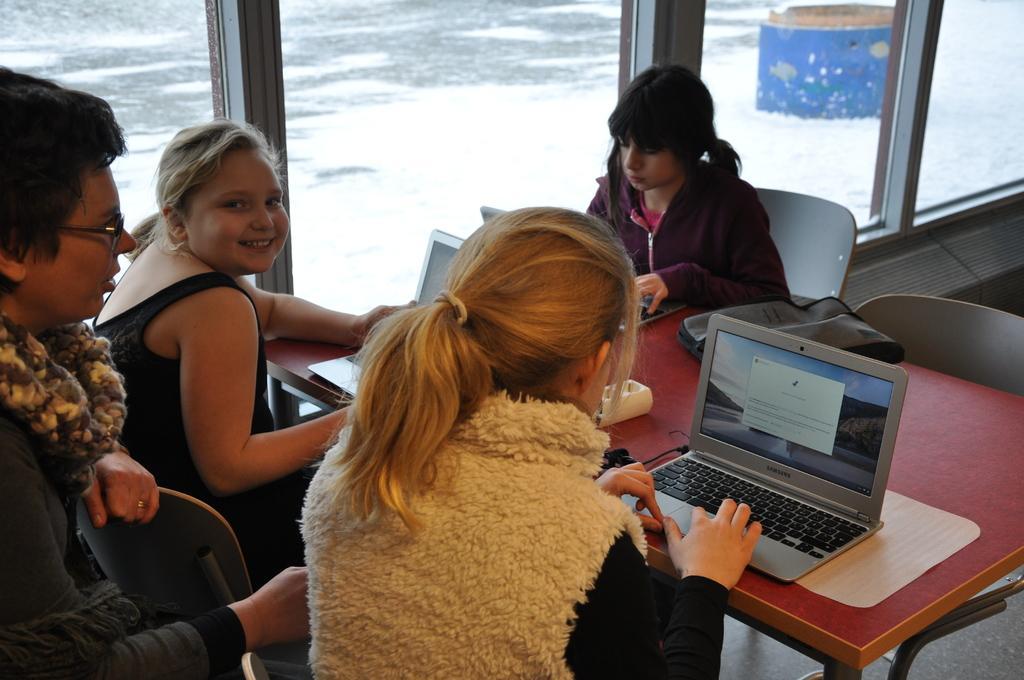How would you summarize this image in a sentence or two? In this picture we can see three girls and a woman sitting on chairs and in front of them we can see laptops, bag on the table and from glass windows we can see an object on the ground. 